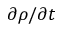<formula> <loc_0><loc_0><loc_500><loc_500>\partial \rho / \partial t</formula> 